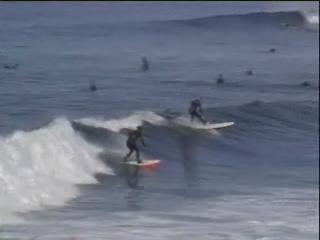How many are surfing?
Answer briefly. 2. What are the people doing?
Write a very short answer. Surfing. What is this person riding?
Concise answer only. Surfboard. What season is it?
Write a very short answer. Summer. Are there waves?
Keep it brief. Yes. How many people are surfing in this picture?
Give a very brief answer. 2. What is the person laying on?
Answer briefly. Surfboard. Are they swimming?
Keep it brief. No. What is on the ground?
Concise answer only. Water. Do the waves look dangerous?
Short answer required. No. 